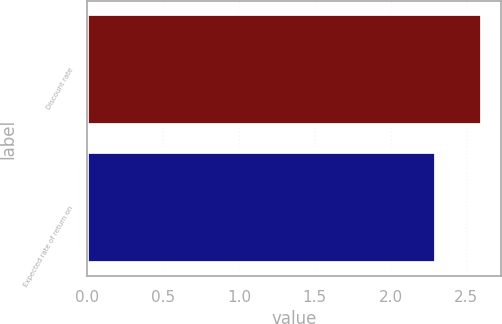Convert chart to OTSL. <chart><loc_0><loc_0><loc_500><loc_500><bar_chart><fcel>Discount rate<fcel>Expected rate of return on<nl><fcel>2.6<fcel>2.3<nl></chart> 